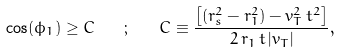Convert formula to latex. <formula><loc_0><loc_0><loc_500><loc_500>\cos ( \phi _ { 1 } ) \geq C \quad ; \quad C \equiv \frac { \left [ ( r _ { s } ^ { 2 } - r _ { 1 } ^ { 2 } ) - v _ { T } ^ { 2 } \, t ^ { 2 } \right ] } { 2 \, r _ { 1 } \, t \, | v _ { T } | } ,</formula> 